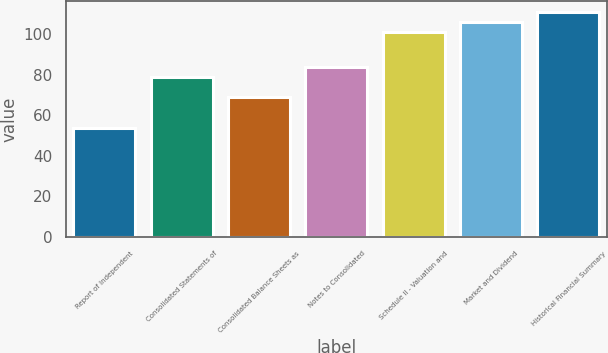<chart> <loc_0><loc_0><loc_500><loc_500><bar_chart><fcel>Report of Independent<fcel>Consolidated Statements of<fcel>Consolidated Balance Sheets as<fcel>Notes to Consolidated<fcel>Schedule II - Valuation and<fcel>Market and Dividend<fcel>Historical Financial Summary<nl><fcel>54<fcel>79<fcel>69<fcel>84<fcel>101<fcel>106<fcel>111<nl></chart> 